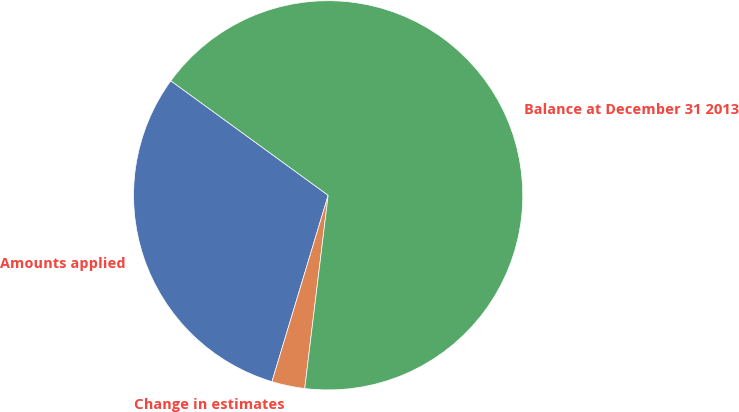Convert chart. <chart><loc_0><loc_0><loc_500><loc_500><pie_chart><fcel>Amounts applied<fcel>Change in estimates<fcel>Balance at December 31 2013<nl><fcel>30.35%<fcel>2.74%<fcel>66.91%<nl></chart> 